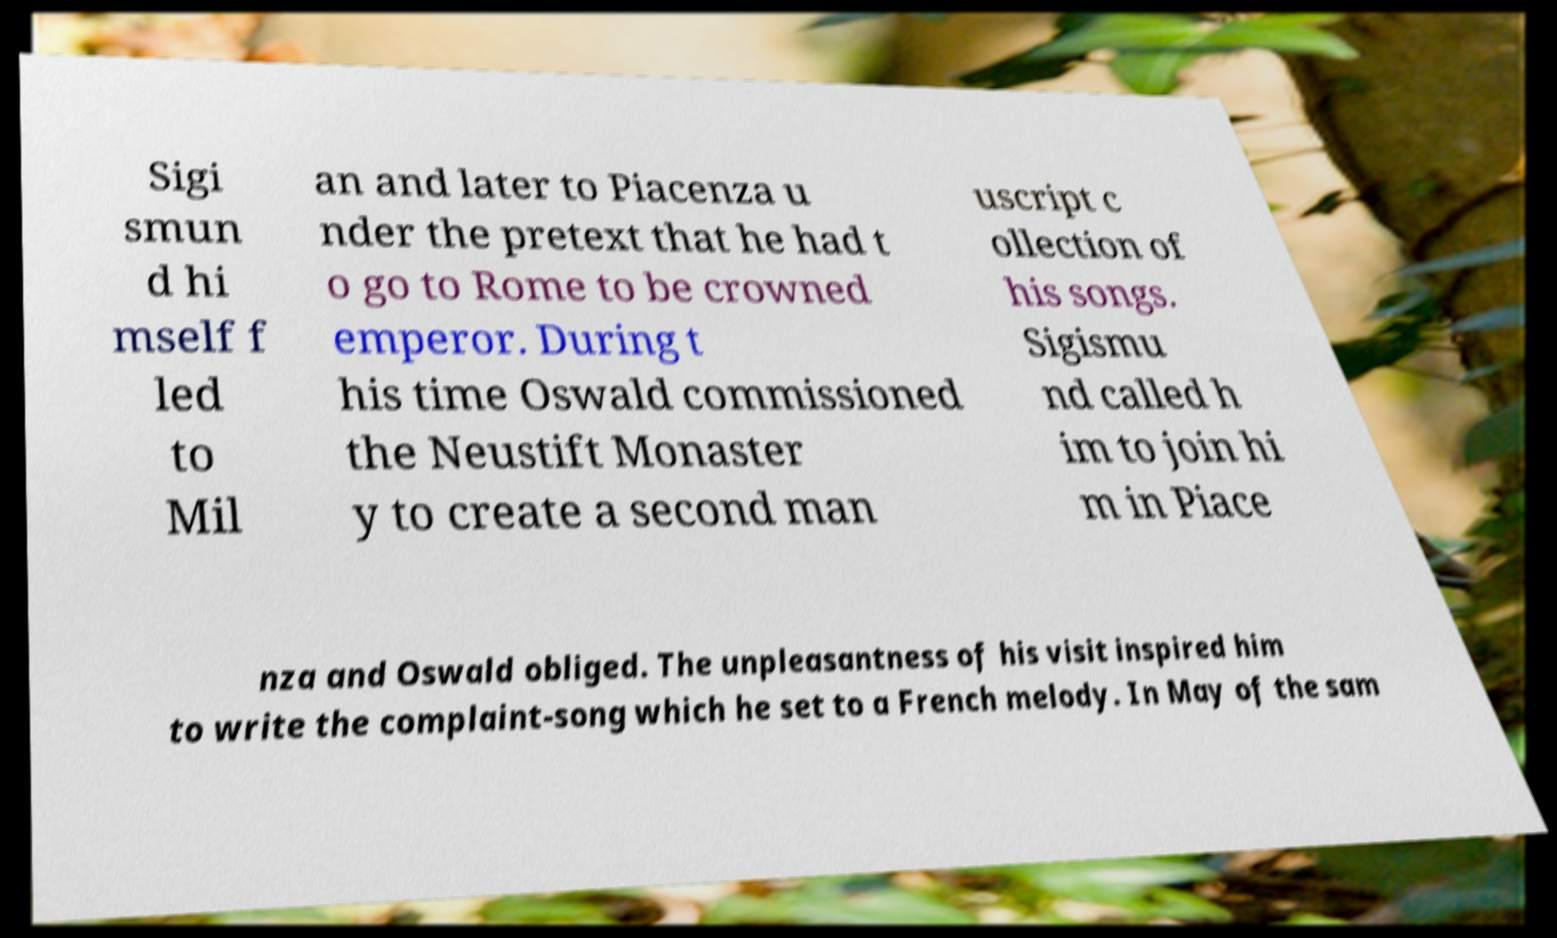Could you extract and type out the text from this image? Sigi smun d hi mself f led to Mil an and later to Piacenza u nder the pretext that he had t o go to Rome to be crowned emperor. During t his time Oswald commissioned the Neustift Monaster y to create a second man uscript c ollection of his songs. Sigismu nd called h im to join hi m in Piace nza and Oswald obliged. The unpleasantness of his visit inspired him to write the complaint-song which he set to a French melody. In May of the sam 